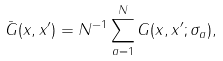<formula> <loc_0><loc_0><loc_500><loc_500>\bar { G } ( x , x ^ { \prime } ) = N ^ { - 1 } \sum _ { a = 1 } ^ { N } G ( x , x ^ { \prime } ; \sigma _ { a } ) ,</formula> 